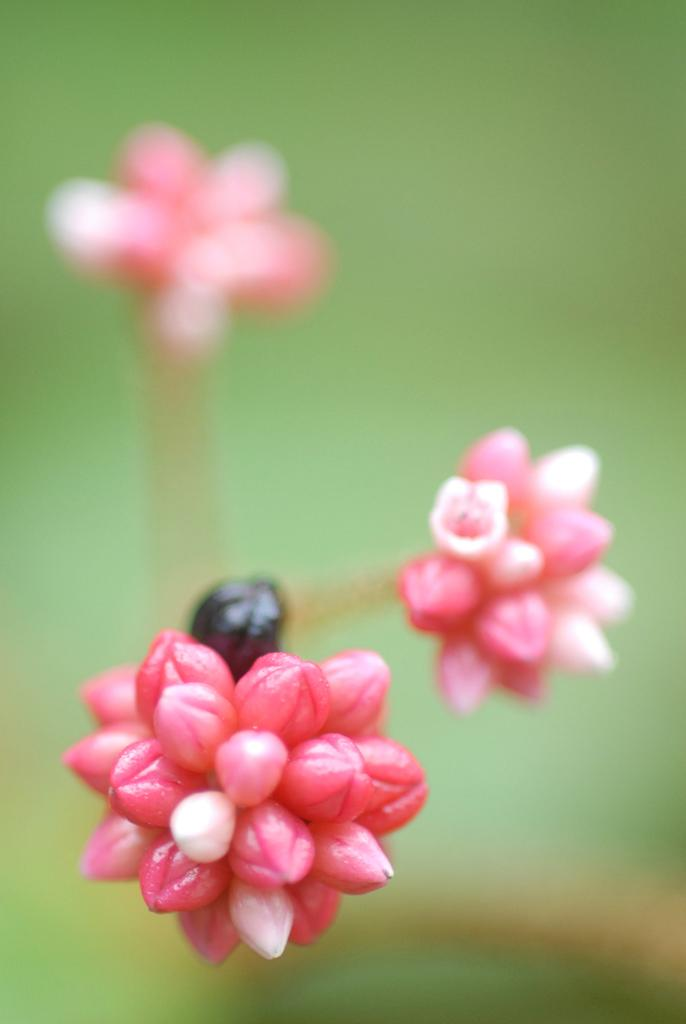What type of flowers are in the image? There are bud flowers in the image. What colors are the bud flowers? The bud flowers are pink and pale pink in color. What can be seen in the background of the image? The background of the image is greenish and blurred. What type of pain is the kitten experiencing in the image? There is no kitten present in the image, so it is not possible to determine if a kitten is experiencing any pain. 